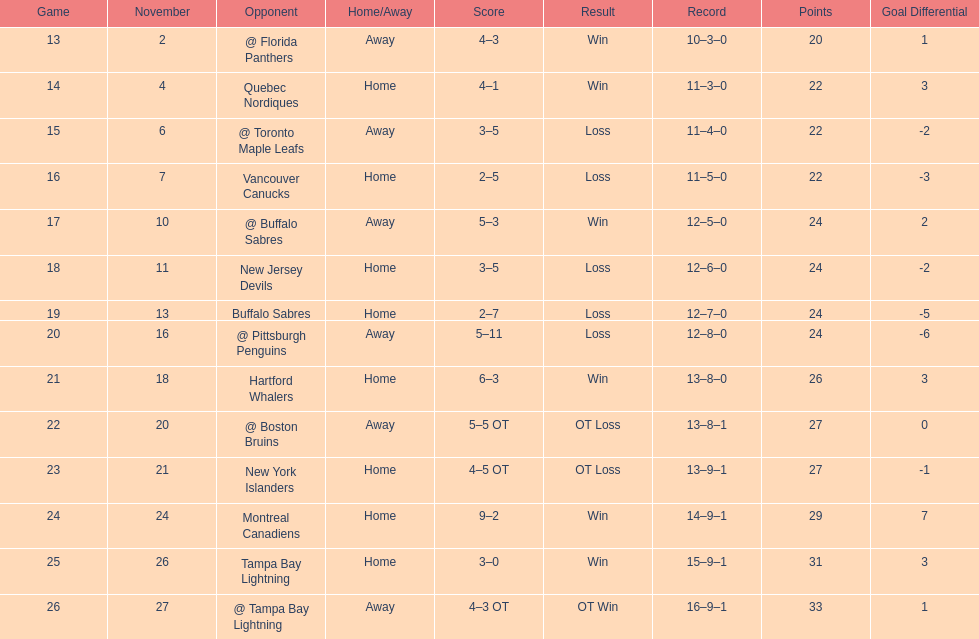What was the number of wins the philadelphia flyers had? 35. 